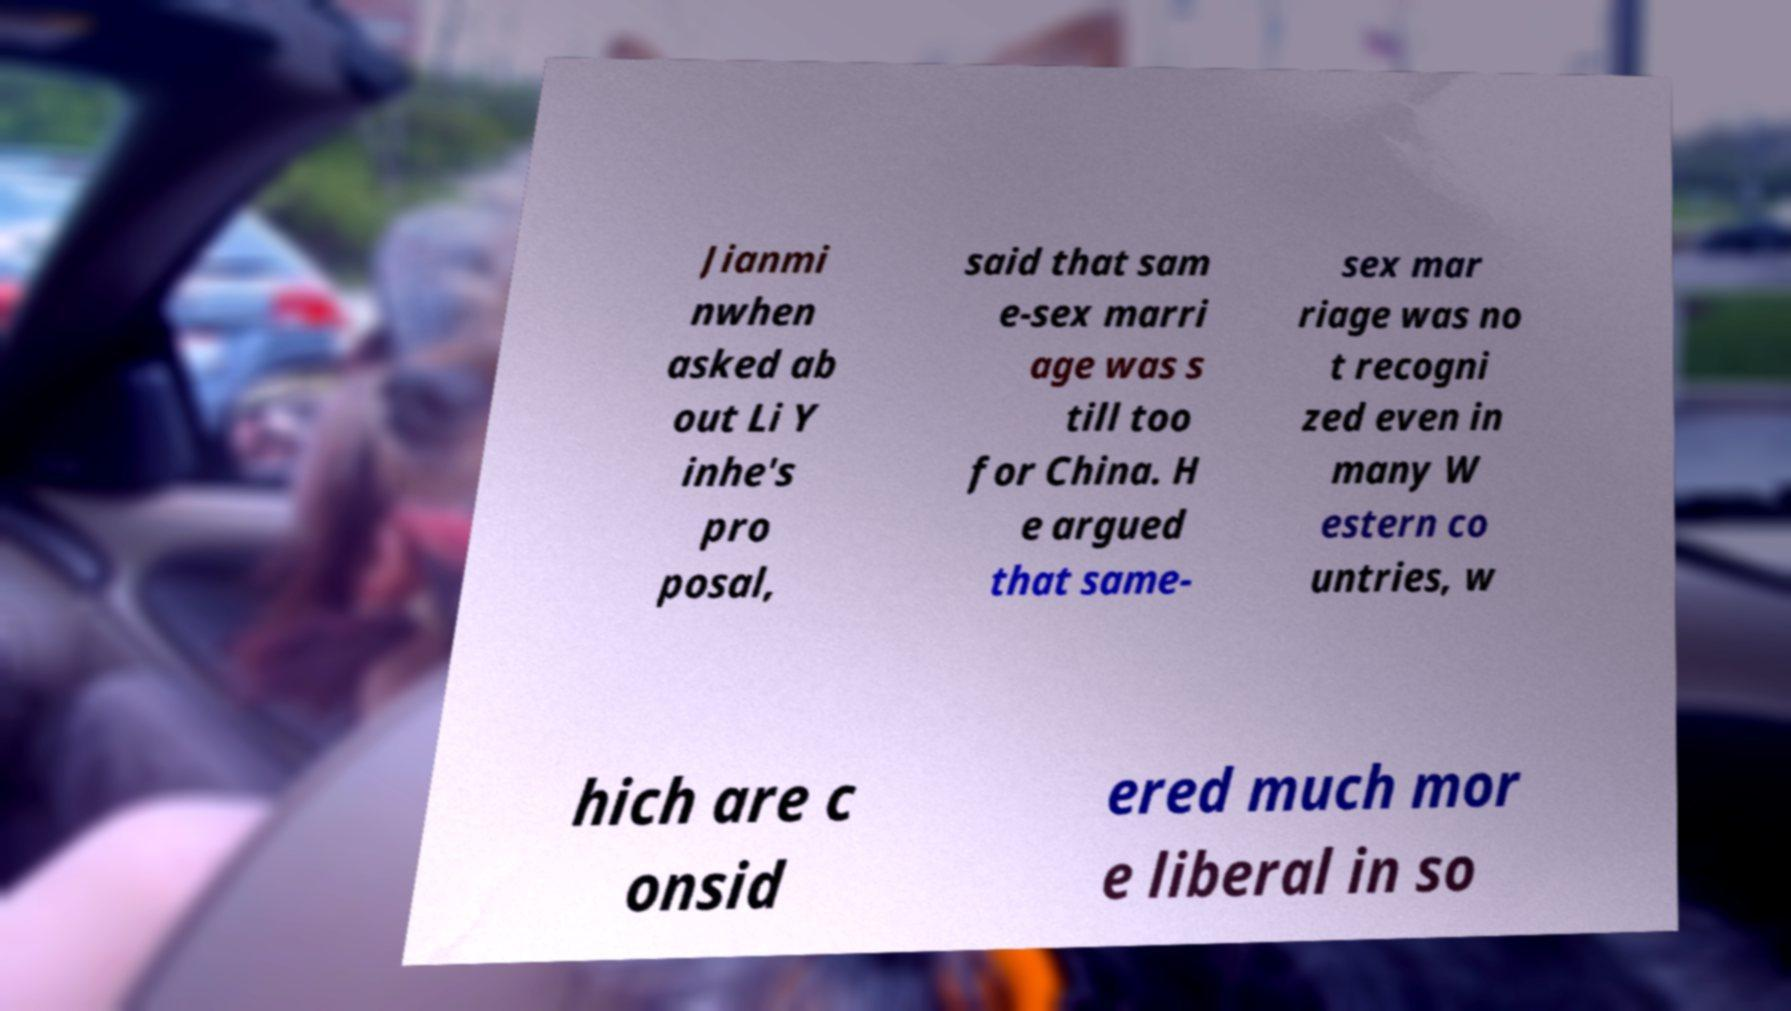What messages or text are displayed in this image? I need them in a readable, typed format. Jianmi nwhen asked ab out Li Y inhe's pro posal, said that sam e-sex marri age was s till too for China. H e argued that same- sex mar riage was no t recogni zed even in many W estern co untries, w hich are c onsid ered much mor e liberal in so 